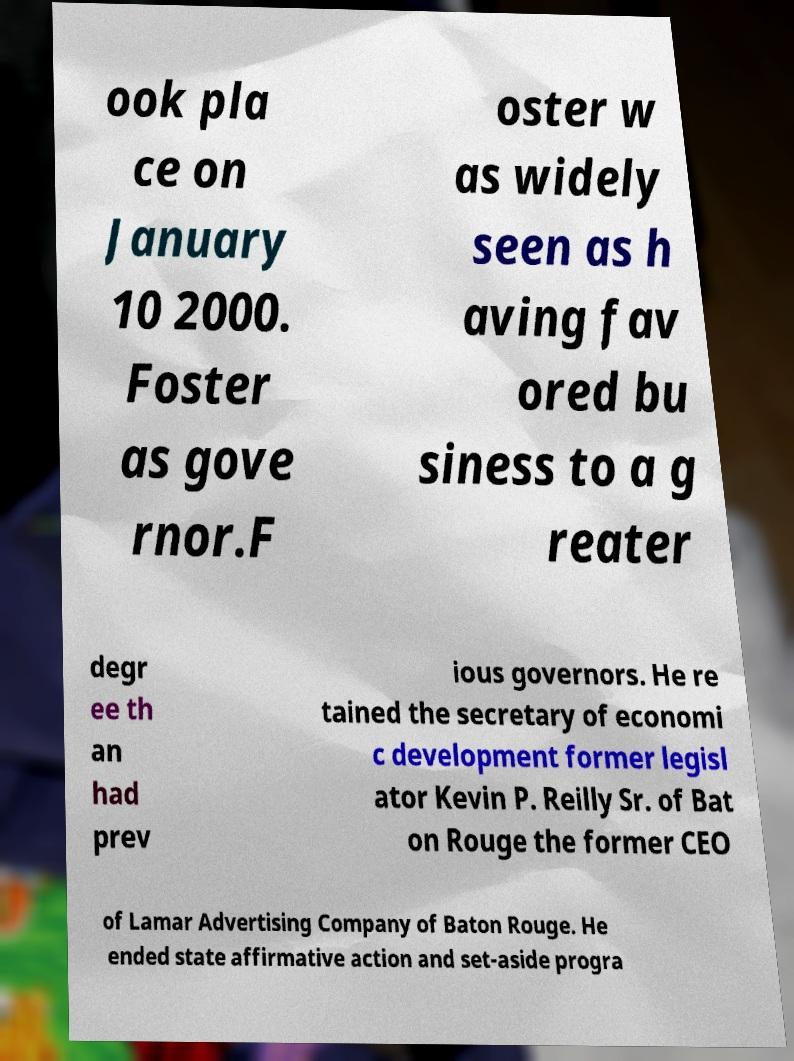What messages or text are displayed in this image? I need them in a readable, typed format. ook pla ce on January 10 2000. Foster as gove rnor.F oster w as widely seen as h aving fav ored bu siness to a g reater degr ee th an had prev ious governors. He re tained the secretary of economi c development former legisl ator Kevin P. Reilly Sr. of Bat on Rouge the former CEO of Lamar Advertising Company of Baton Rouge. He ended state affirmative action and set-aside progra 